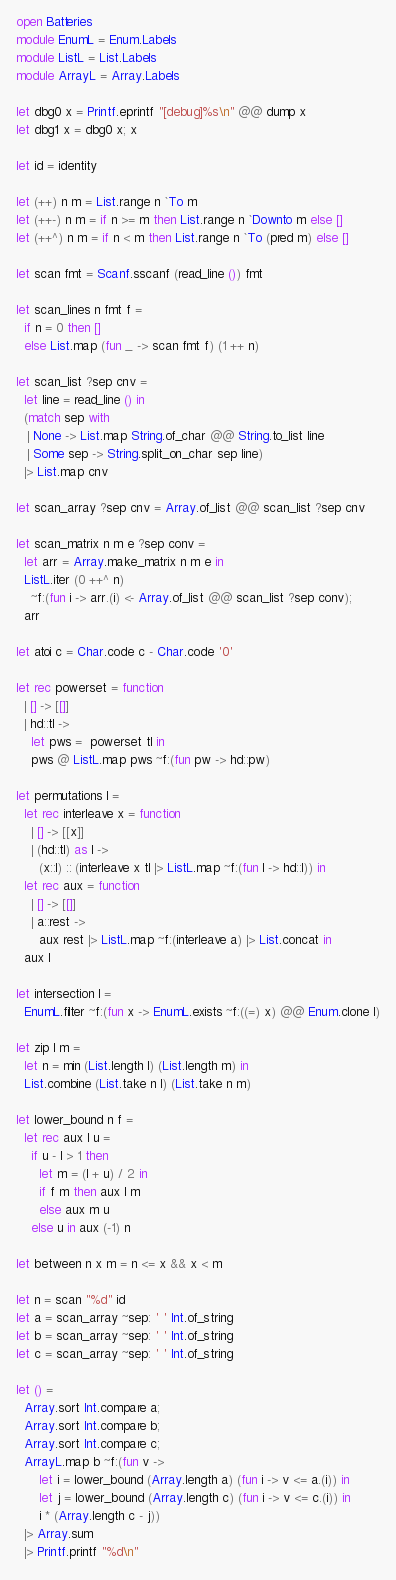Convert code to text. <code><loc_0><loc_0><loc_500><loc_500><_OCaml_>open Batteries
module EnumL = Enum.Labels
module ListL = List.Labels
module ArrayL = Array.Labels

let dbg0 x = Printf.eprintf "[debug]%s\n" @@ dump x
let dbg1 x = dbg0 x; x

let id = identity

let (++) n m = List.range n `To m
let (++-) n m = if n >= m then List.range n `Downto m else []
let (++^) n m = if n < m then List.range n `To (pred m) else []

let scan fmt = Scanf.sscanf (read_line ()) fmt

let scan_lines n fmt f =
  if n = 0 then []
  else List.map (fun _ -> scan fmt f) (1 ++ n)

let scan_list ?sep cnv =
  let line = read_line () in
  (match sep with
   | None -> List.map String.of_char @@ String.to_list line
   | Some sep -> String.split_on_char sep line)
  |> List.map cnv

let scan_array ?sep cnv = Array.of_list @@ scan_list ?sep cnv

let scan_matrix n m e ?sep conv =
  let arr = Array.make_matrix n m e in
  ListL.iter (0 ++^ n)
    ~f:(fun i -> arr.(i) <- Array.of_list @@ scan_list ?sep conv);
  arr

let atoi c = Char.code c - Char.code '0'

let rec powerset = function
  | [] -> [[]]
  | hd::tl ->
    let pws =  powerset tl in
    pws @ ListL.map pws ~f:(fun pw -> hd::pw)

let permutations l =
  let rec interleave x = function
    | [] -> [[x]]
    | (hd::tl) as l ->
      (x::l) :: (interleave x tl |> ListL.map ~f:(fun l -> hd::l)) in
  let rec aux = function
    | [] -> [[]]
    | a::rest ->
      aux rest |> ListL.map ~f:(interleave a) |> List.concat in
  aux l

let intersection l =
  EnumL.filter ~f:(fun x -> EnumL.exists ~f:((=) x) @@ Enum.clone l)

let zip l m =
  let n = min (List.length l) (List.length m) in
  List.combine (List.take n l) (List.take n m)

let lower_bound n f =
  let rec aux l u =
    if u - l > 1 then
      let m = (l + u) / 2 in
      if f m then aux l m
      else aux m u
    else u in aux (-1) n

let between n x m = n <= x && x < m

let n = scan "%d" id
let a = scan_array ~sep: ' ' Int.of_string
let b = scan_array ~sep: ' ' Int.of_string
let c = scan_array ~sep: ' ' Int.of_string

let () =
  Array.sort Int.compare a;
  Array.sort Int.compare b;
  Array.sort Int.compare c;
  ArrayL.map b ~f:(fun v ->
      let i = lower_bound (Array.length a) (fun i -> v <= a.(i)) in
      let j = lower_bound (Array.length c) (fun i -> v <= c.(i)) in
      i * (Array.length c - j))
  |> Array.sum
  |> Printf.printf "%d\n"
</code> 